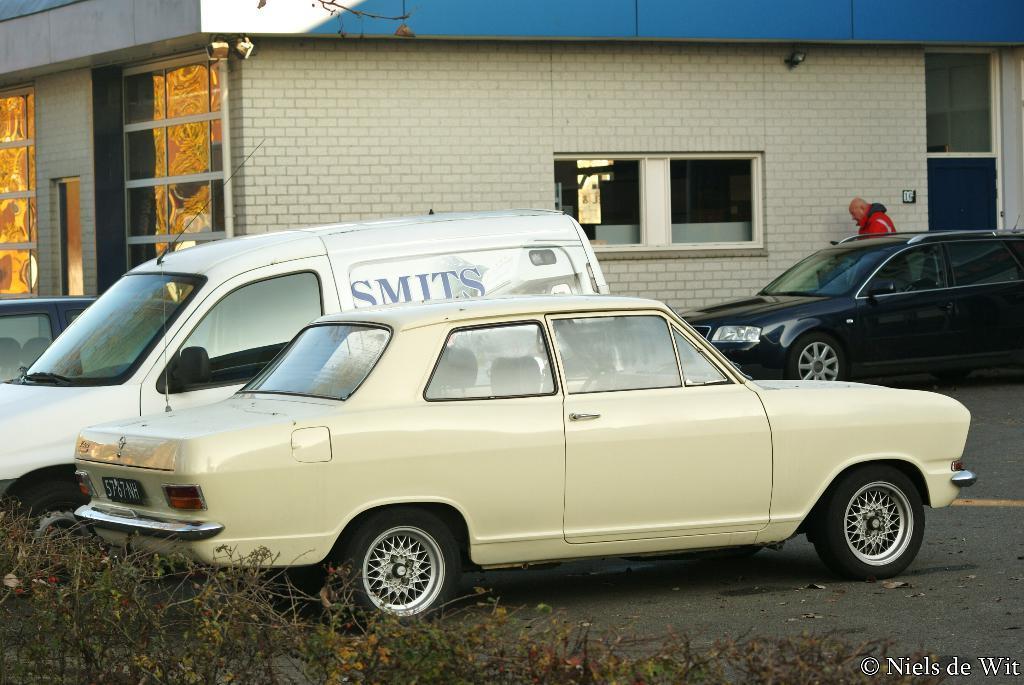Could you give a brief overview of what you see in this image? In this image I can see some vehicles on the road. I can see a man standing near the wall. In the background, I can see a building with windows. 